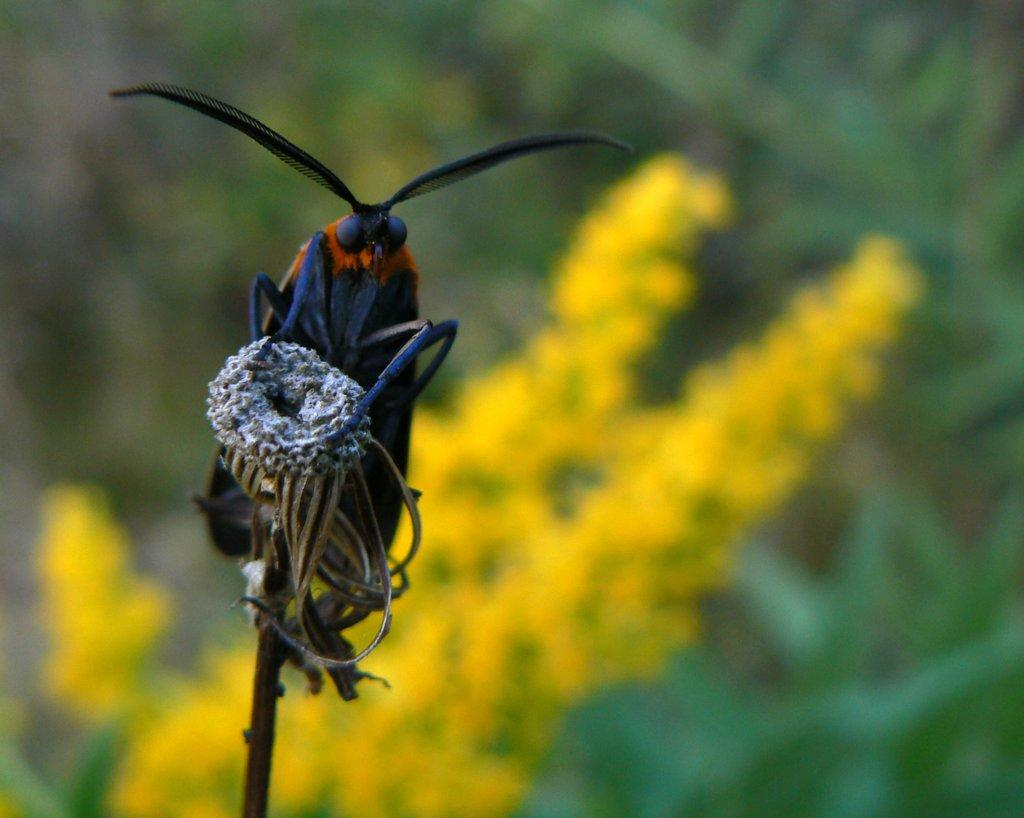What is the main subject of the image? There is a fly in the image. Can you describe the fly's appearance? The fly is blue in color. Where is the fly located in the image? The fly is on a stem. What can be seen in the background of the image? There are yellow flowers and green leaves in the background of the image. How is the background of the image depicted? The background is blurred. How many sheep are visible in the office setting in the image? There are no sheep or office setting present in the image; it features a blue fly on a stem with a blurred background of yellow flowers and green leaves. 